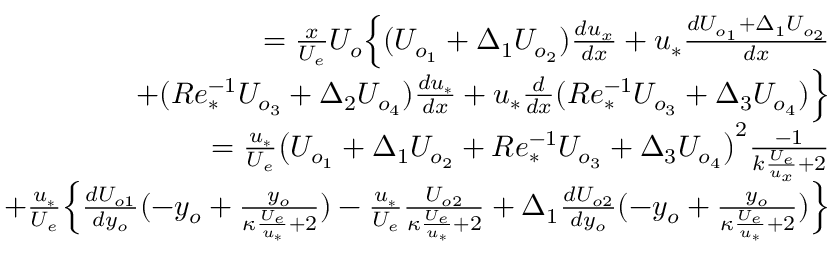<formula> <loc_0><loc_0><loc_500><loc_500>\begin{array} { r } { = \frac { x } { U _ { e } } U _ { o } \left \{ ( U _ { o _ { 1 } } + \Delta _ { 1 } U _ { o _ { 2 } } ) \frac { d u _ { x } } { d x } + u _ { * } \frac { d U _ { o _ { 1 } } + \Delta _ { 1 } U _ { o _ { 2 } } } { d x } } \\ { + ( R e _ { * } ^ { - 1 } U _ { o _ { 3 } } + \Delta _ { 2 } U _ { o _ { 4 } } ) \frac { d u _ { * } } { d x } + u _ { * } \frac { d } { d x } ( R e _ { * } ^ { - 1 } U _ { o _ { 3 } } + \Delta _ { 3 } U _ { o _ { 4 } } ) \right \} } \\ { = \frac { u _ { * } } { U _ { e } } \left ( U _ { o _ { 1 } } + \Delta _ { 1 } U _ { o _ { 2 } } + R e _ { * } ^ { - 1 } U _ { o _ { 3 } } + \Delta _ { 3 } U _ { o _ { 4 } } \right ) ^ { 2 } \frac { - 1 } { k \frac { U _ { e } } { u _ { x } } + 2 } } \\ { + \frac { u _ { * } } { U _ { e } } \left \{ \frac { d U _ { o 1 } } { d y _ { o } } ( - y _ { o } + \frac { y _ { o } } { \kappa \frac { U _ { e } } { u _ { * } } + 2 } ) - \frac { u _ { * } } { U _ { e } } \frac { U _ { o 2 } } { \kappa \frac { U _ { e } } { u _ { * } } + 2 } + \Delta _ { 1 } \frac { d U _ { o 2 } } { d y _ { o } } ( - y _ { o } + \frac { y _ { o } } { \kappa \frac { U _ { e } } { u _ { * } } + 2 } ) \right \} } \end{array}</formula> 